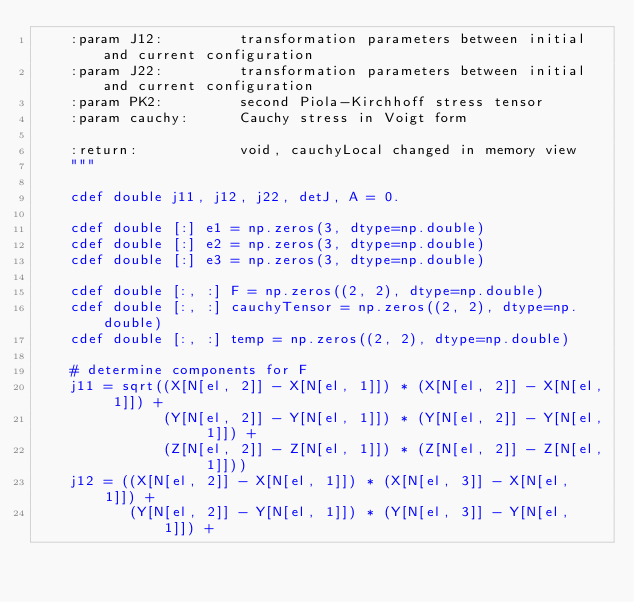<code> <loc_0><loc_0><loc_500><loc_500><_Cython_>    :param J12:         transformation parameters between initial and current configuration
    :param J22:         transformation parameters between initial and current configuration
    :param PK2:         second Piola-Kirchhoff stress tensor
    :param cauchy:      Cauchy stress in Voigt form
    
    :return:            void, cauchyLocal changed in memory view
    """

    cdef double j11, j12, j22, detJ, A = 0.

    cdef double [:] e1 = np.zeros(3, dtype=np.double)
    cdef double [:] e2 = np.zeros(3, dtype=np.double)
    cdef double [:] e3 = np.zeros(3, dtype=np.double)

    cdef double [:, :] F = np.zeros((2, 2), dtype=np.double)
    cdef double [:, :] cauchyTensor = np.zeros((2, 2), dtype=np.double)
    cdef double [:, :] temp = np.zeros((2, 2), dtype=np.double)

    # determine components for F
    j11 = sqrt((X[N[el, 2]] - X[N[el, 1]]) * (X[N[el, 2]] - X[N[el, 1]]) +
               (Y[N[el, 2]] - Y[N[el, 1]]) * (Y[N[el, 2]] - Y[N[el, 1]]) +
               (Z[N[el, 2]] - Z[N[el, 1]]) * (Z[N[el, 2]] - Z[N[el, 1]]))
    j12 = ((X[N[el, 2]] - X[N[el, 1]]) * (X[N[el, 3]] - X[N[el, 1]]) +
           (Y[N[el, 2]] - Y[N[el, 1]]) * (Y[N[el, 3]] - Y[N[el, 1]]) +</code> 